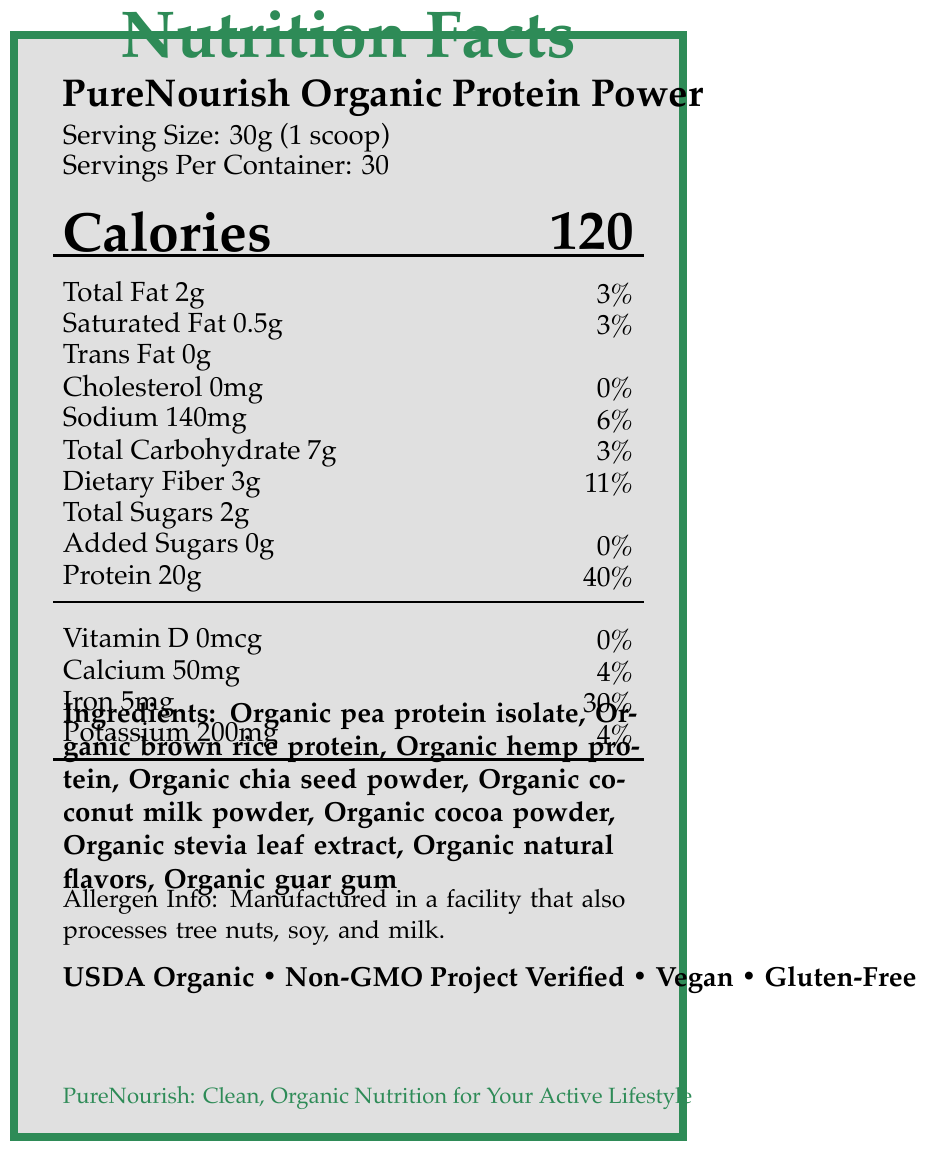what is the serving size? The serving size is listed as "30g (1 scoop)" in the document.
Answer: 30g (1 scoop) how many servings are there per container? The document specifies "Servings Per Container: 30".
Answer: 30 how many calories are there per serving? The document indicates "Calories: 120" next to the product name.
Answer: 120 calories how much protein is in one serving? The protein content per serving is listed as "Protein 20g".
Answer: 20g what is the total fat content per serving? Under the nutrient table, the total fat per serving is listed as "Total Fat 2g".
Answer: 2g what is the percentage daily value of dietary fiber per serving? The percentage daily value of dietary fiber is listed as "Dietary Fiber 3g 11%".
Answer: 11% how much sugar is in one serving? The document shows "Total Sugars 2g" under the nutrient table.
Answer: 2g are there any added sugars? The document specifies "Added Sugars 0g".
Answer: No how much iron is in one serving? The amount of iron per serving is listed as "Iron 5mg 30%".
Answer: 5mg what type of proteins are used in this product? The listed ingredients include "Organic pea protein isolate, Organic brown rice protein, Organic hemp protein".
Answer: Pea, brown rice, hemp which of the following claims are made about the product? A. USDA Organic B. Non-GMO Project Verified C. Contains artificial sweeteners The document lists "USDA Organic" and "Non-GMO Project Verified" among the claims, whereas it specifies "No artificial sweeteners".
Answer: A, B what is the percentage daily value of sodium per serving? The document provides "Sodium 140mg 6%" under the nutrient table.
Answer: 6% which certification ensures the product is suitable for vegans? A. Non-GMO Project Verified B. USDA Organic C. Certified Vegan The certification that ensures suitability for vegans is "Certified Vegan".
Answer: C is this product gluten-free? One of the claims listed is "Gluten-Free".
Answer: Yes are artificial sweeteners used in this product? The document claims "No artificial sweeteners".
Answer: No summarize the main idea of the document. The document details the nutritional facts, ingredients, allergen information, health claims, and certifications for the PureNourish Organic Protein Power. It emphasizes the product's clean, organic composition and its alignment with various health certifications like USDA Organic, Non-GMO Project Verified, Vegan, and Gluten-Free.
Answer: The document provides nutritional information for PureNourish Organic Protein Power, highlighting its clean, organic ingredients and various health certifications. It specifies serving size, calories, macronutrients, micronutrients, claims, and directions. how is the product packaged? The document does not provide details about the specific packaging method or material.
Answer: Not enough information 